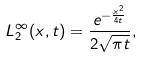Convert formula to latex. <formula><loc_0><loc_0><loc_500><loc_500>L _ { 2 } ^ { \infty } ( x , t ) = \frac { e ^ { - \frac { x ^ { 2 } } { 4 t } } } { 2 \sqrt { \pi t } } ,</formula> 